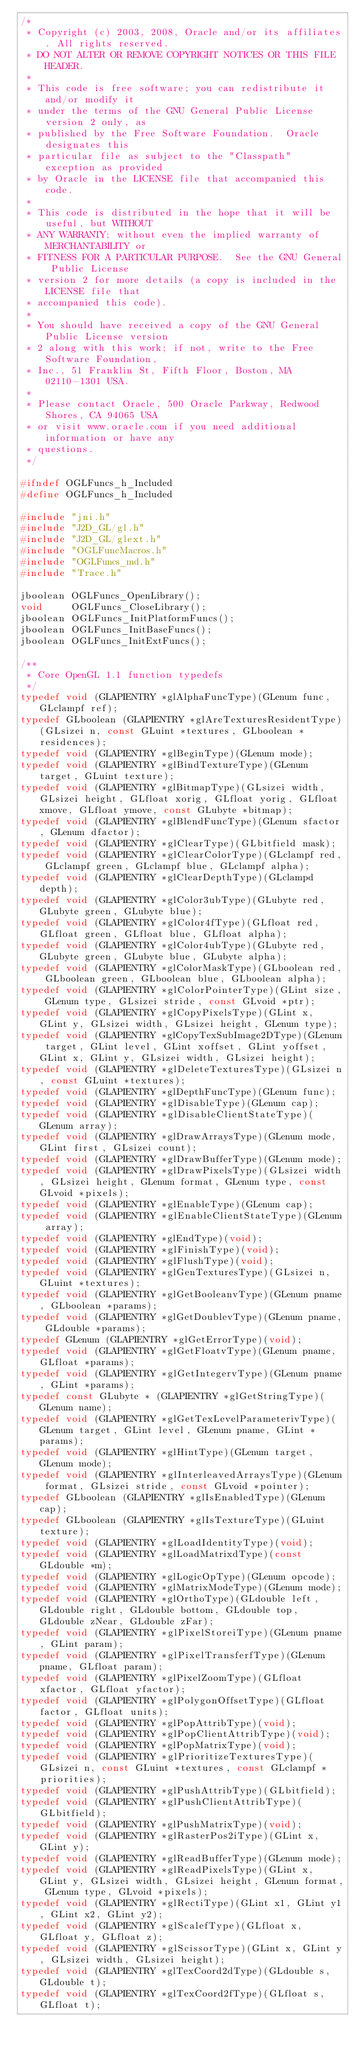Convert code to text. <code><loc_0><loc_0><loc_500><loc_500><_C_>/*
 * Copyright (c) 2003, 2008, Oracle and/or its affiliates. All rights reserved.
 * DO NOT ALTER OR REMOVE COPYRIGHT NOTICES OR THIS FILE HEADER.
 *
 * This code is free software; you can redistribute it and/or modify it
 * under the terms of the GNU General Public License version 2 only, as
 * published by the Free Software Foundation.  Oracle designates this
 * particular file as subject to the "Classpath" exception as provided
 * by Oracle in the LICENSE file that accompanied this code.
 *
 * This code is distributed in the hope that it will be useful, but WITHOUT
 * ANY WARRANTY; without even the implied warranty of MERCHANTABILITY or
 * FITNESS FOR A PARTICULAR PURPOSE.  See the GNU General Public License
 * version 2 for more details (a copy is included in the LICENSE file that
 * accompanied this code).
 *
 * You should have received a copy of the GNU General Public License version
 * 2 along with this work; if not, write to the Free Software Foundation,
 * Inc., 51 Franklin St, Fifth Floor, Boston, MA 02110-1301 USA.
 *
 * Please contact Oracle, 500 Oracle Parkway, Redwood Shores, CA 94065 USA
 * or visit www.oracle.com if you need additional information or have any
 * questions.
 */

#ifndef OGLFuncs_h_Included
#define OGLFuncs_h_Included

#include "jni.h"
#include "J2D_GL/gl.h"
#include "J2D_GL/glext.h"
#include "OGLFuncMacros.h"
#include "OGLFuncs_md.h"
#include "Trace.h"

jboolean OGLFuncs_OpenLibrary();
void     OGLFuncs_CloseLibrary();
jboolean OGLFuncs_InitPlatformFuncs();
jboolean OGLFuncs_InitBaseFuncs();
jboolean OGLFuncs_InitExtFuncs();

/**
 * Core OpenGL 1.1 function typedefs
 */
typedef void (GLAPIENTRY *glAlphaFuncType)(GLenum func, GLclampf ref);
typedef GLboolean (GLAPIENTRY *glAreTexturesResidentType)(GLsizei n, const GLuint *textures, GLboolean *residences);
typedef void (GLAPIENTRY *glBeginType)(GLenum mode);
typedef void (GLAPIENTRY *glBindTextureType)(GLenum target, GLuint texture);
typedef void (GLAPIENTRY *glBitmapType)(GLsizei width, GLsizei height, GLfloat xorig, GLfloat yorig, GLfloat xmove, GLfloat ymove, const GLubyte *bitmap);
typedef void (GLAPIENTRY *glBlendFuncType)(GLenum sfactor, GLenum dfactor);
typedef void (GLAPIENTRY *glClearType)(GLbitfield mask);
typedef void (GLAPIENTRY *glClearColorType)(GLclampf red, GLclampf green, GLclampf blue, GLclampf alpha);
typedef void (GLAPIENTRY *glClearDepthType)(GLclampd depth);
typedef void (GLAPIENTRY *glColor3ubType)(GLubyte red, GLubyte green, GLubyte blue);
typedef void (GLAPIENTRY *glColor4fType)(GLfloat red, GLfloat green, GLfloat blue, GLfloat alpha);
typedef void (GLAPIENTRY *glColor4ubType)(GLubyte red, GLubyte green, GLubyte blue, GLubyte alpha);
typedef void (GLAPIENTRY *glColorMaskType)(GLboolean red, GLboolean green, GLboolean blue, GLboolean alpha);
typedef void (GLAPIENTRY *glColorPointerType)(GLint size, GLenum type, GLsizei stride, const GLvoid *ptr);
typedef void (GLAPIENTRY *glCopyPixelsType)(GLint x, GLint y, GLsizei width, GLsizei height, GLenum type);
typedef void (GLAPIENTRY *glCopyTexSubImage2DType)(GLenum target, GLint level, GLint xoffset, GLint yoffset, GLint x, GLint y, GLsizei width, GLsizei height);
typedef void (GLAPIENTRY *glDeleteTexturesType)(GLsizei n, const GLuint *textures);
typedef void (GLAPIENTRY *glDepthFuncType)(GLenum func);
typedef void (GLAPIENTRY *glDisableType)(GLenum cap);
typedef void (GLAPIENTRY *glDisableClientStateType)(GLenum array);
typedef void (GLAPIENTRY *glDrawArraysType)(GLenum mode, GLint first, GLsizei count);
typedef void (GLAPIENTRY *glDrawBufferType)(GLenum mode);
typedef void (GLAPIENTRY *glDrawPixelsType)(GLsizei width, GLsizei height, GLenum format, GLenum type, const GLvoid *pixels);
typedef void (GLAPIENTRY *glEnableType)(GLenum cap);
typedef void (GLAPIENTRY *glEnableClientStateType)(GLenum array);
typedef void (GLAPIENTRY *glEndType)(void);
typedef void (GLAPIENTRY *glFinishType)(void);
typedef void (GLAPIENTRY *glFlushType)(void);
typedef void (GLAPIENTRY *glGenTexturesType)(GLsizei n, GLuint *textures);
typedef void (GLAPIENTRY *glGetBooleanvType)(GLenum pname, GLboolean *params);
typedef void (GLAPIENTRY *glGetDoublevType)(GLenum pname, GLdouble *params);
typedef GLenum (GLAPIENTRY *glGetErrorType)(void);
typedef void (GLAPIENTRY *glGetFloatvType)(GLenum pname, GLfloat *params);
typedef void (GLAPIENTRY *glGetIntegervType)(GLenum pname, GLint *params);
typedef const GLubyte * (GLAPIENTRY *glGetStringType)(GLenum name);
typedef void (GLAPIENTRY *glGetTexLevelParameterivType)(GLenum target, GLint level, GLenum pname, GLint *params);
typedef void (GLAPIENTRY *glHintType)(GLenum target, GLenum mode);
typedef void (GLAPIENTRY *glInterleavedArraysType)(GLenum format, GLsizei stride, const GLvoid *pointer);
typedef GLboolean (GLAPIENTRY *glIsEnabledType)(GLenum cap);
typedef GLboolean (GLAPIENTRY *glIsTextureType)(GLuint texture);
typedef void (GLAPIENTRY *glLoadIdentityType)(void);
typedef void (GLAPIENTRY *glLoadMatrixdType)(const GLdouble *m);
typedef void (GLAPIENTRY *glLogicOpType)(GLenum opcode);
typedef void (GLAPIENTRY *glMatrixModeType)(GLenum mode);
typedef void (GLAPIENTRY *glOrthoType)(GLdouble left, GLdouble right, GLdouble bottom, GLdouble top, GLdouble zNear, GLdouble zFar);
typedef void (GLAPIENTRY *glPixelStoreiType)(GLenum pname, GLint param);
typedef void (GLAPIENTRY *glPixelTransferfType)(GLenum pname, GLfloat param);
typedef void (GLAPIENTRY *glPixelZoomType)(GLfloat xfactor, GLfloat yfactor);
typedef void (GLAPIENTRY *glPolygonOffsetType)(GLfloat factor, GLfloat units);
typedef void (GLAPIENTRY *glPopAttribType)(void);
typedef void (GLAPIENTRY *glPopClientAttribType)(void);
typedef void (GLAPIENTRY *glPopMatrixType)(void);
typedef void (GLAPIENTRY *glPrioritizeTexturesType)(GLsizei n, const GLuint *textures, const GLclampf *priorities);
typedef void (GLAPIENTRY *glPushAttribType)(GLbitfield);
typedef void (GLAPIENTRY *glPushClientAttribType)(GLbitfield);
typedef void (GLAPIENTRY *glPushMatrixType)(void);
typedef void (GLAPIENTRY *glRasterPos2iType)(GLint x, GLint y);
typedef void (GLAPIENTRY *glReadBufferType)(GLenum mode);
typedef void (GLAPIENTRY *glReadPixelsType)(GLint x, GLint y, GLsizei width, GLsizei height, GLenum format, GLenum type, GLvoid *pixels);
typedef void (GLAPIENTRY *glRectiType)(GLint x1, GLint y1, GLint x2, GLint y2);
typedef void (GLAPIENTRY *glScalefType)(GLfloat x, GLfloat y, GLfloat z);
typedef void (GLAPIENTRY *glScissorType)(GLint x, GLint y, GLsizei width, GLsizei height);
typedef void (GLAPIENTRY *glTexCoord2dType)(GLdouble s, GLdouble t);
typedef void (GLAPIENTRY *glTexCoord2fType)(GLfloat s, GLfloat t);</code> 